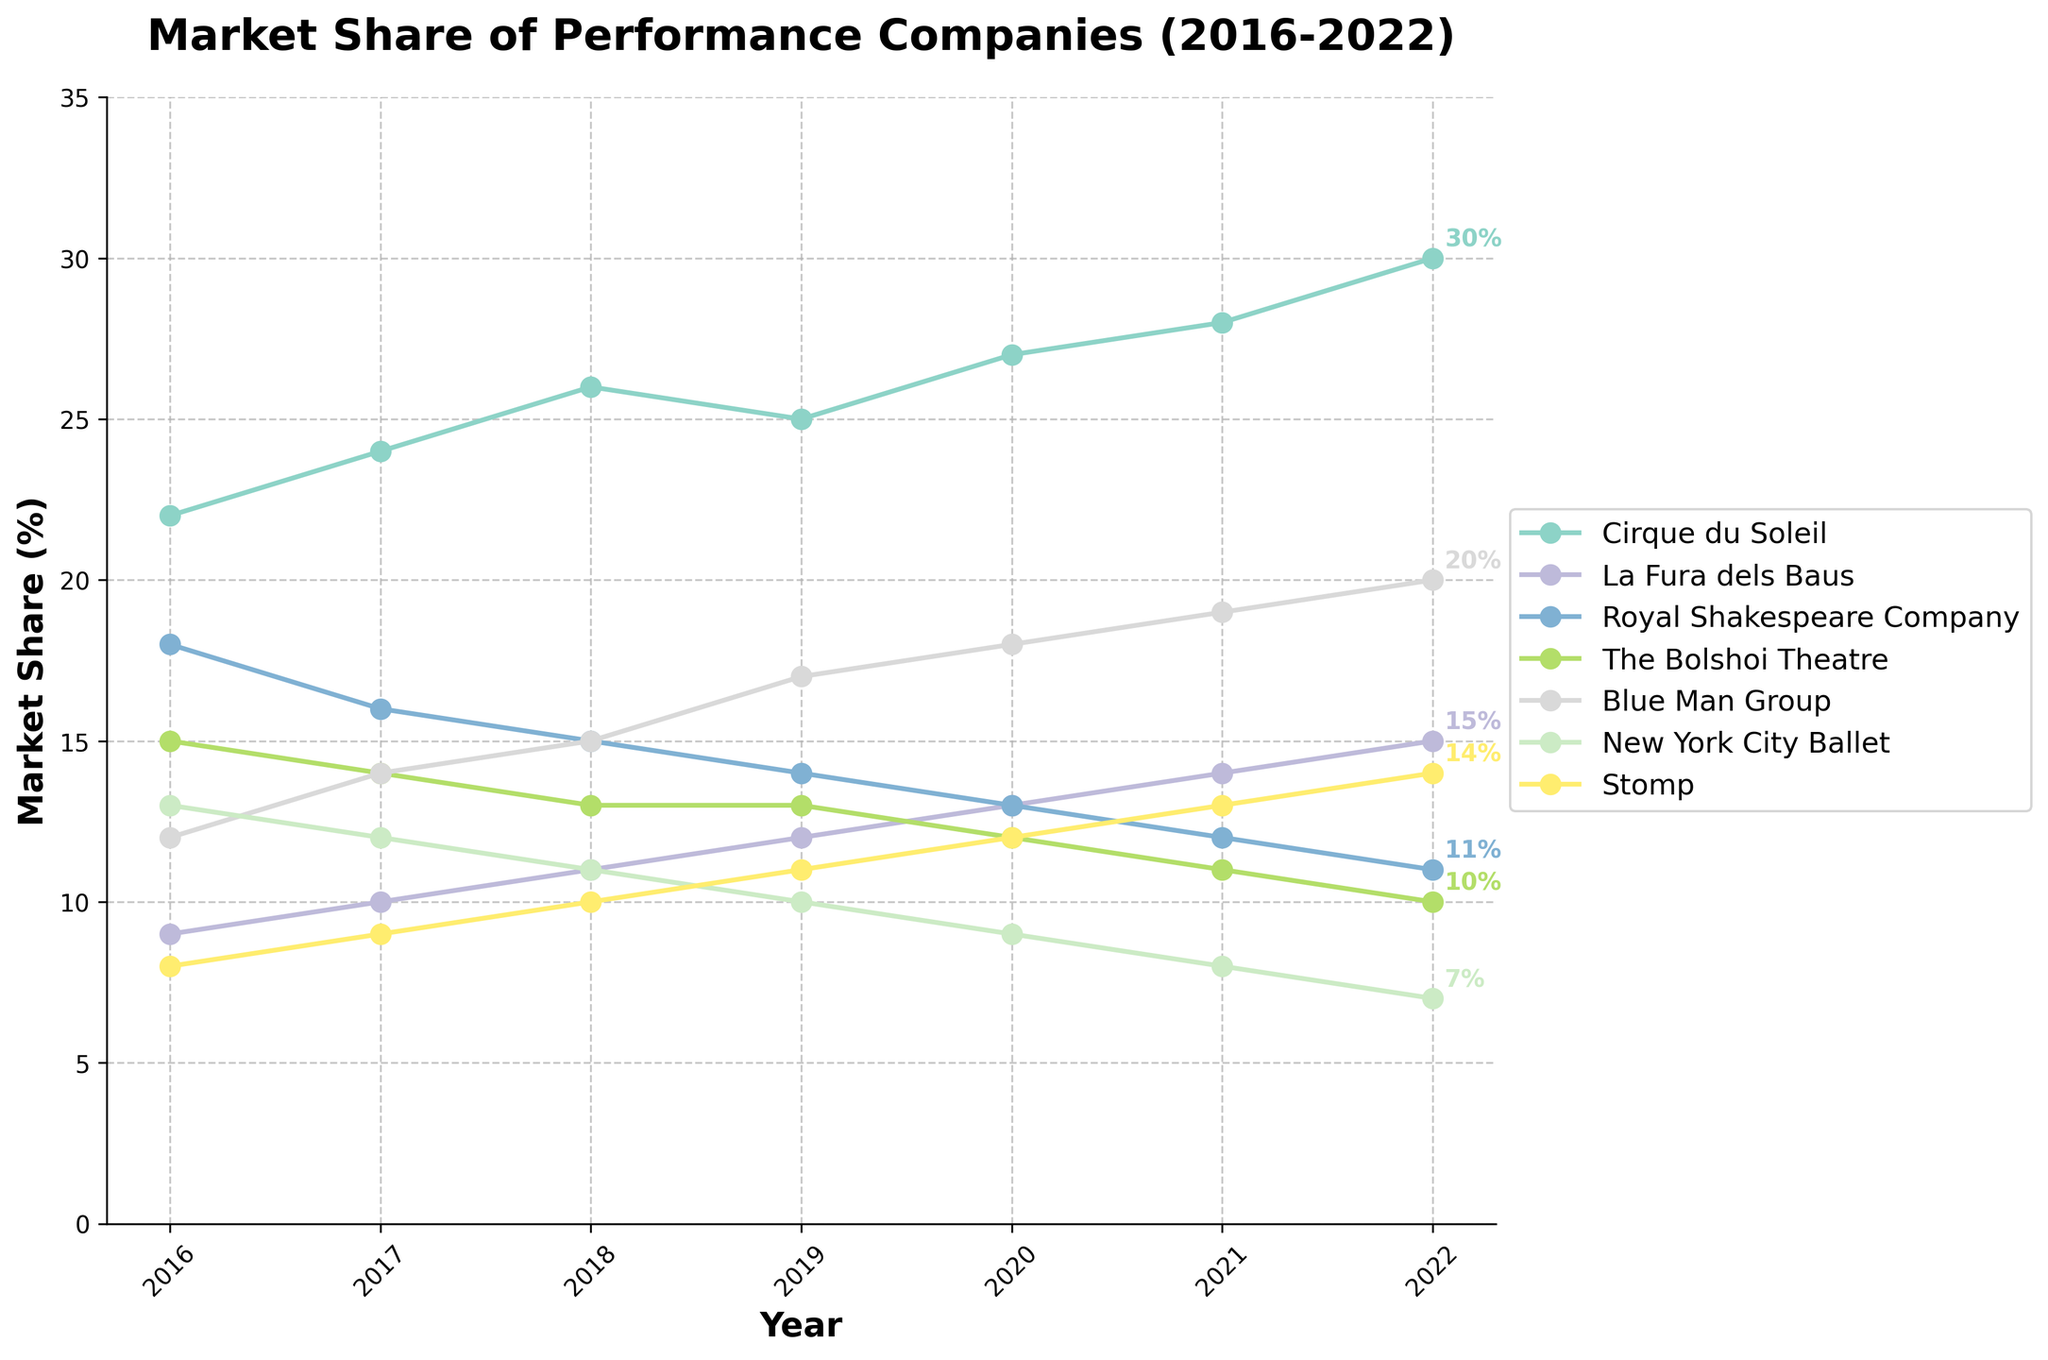What is the title of the plot? The title is usually found at the top of the plot in a larger and bold font. It provides a summary of what the plot is about. Here, the title reads "Market Share of Performance Companies (2016-2022)".
Answer: Market Share of Performance Companies (2016-2022) What are the companies categorized as innovative? The plot uses a distinct color for each company, and the legend on the right side of the plot helps identify these categories. Cirque du Soleil, La Fura dels Baus, Blue Man Group, and Stomp are labeled as innovative performance companies.
Answer: Cirque du Soleil, La Fura dels Baus, Blue Man Group, Stomp What is the range of years shown on the x-axis? The x-axis represents the years, displayed sequentially from left to right. Here, the x-axis starts from 2016 and extends to 2022.
Answer: 2016-2022 Which company had the highest market share in 2022? By looking at the trend lines and the data points labeled for 2022, we see that Cirque du Soleil had the highest market share at 30%.
Answer: Cirque du Soleil How did Blue Man Group’s market share change from 2016 to 2022? Blue Man Group’s market share changes can be traced by following its corresponding trend line across the years 2016 to 2022. It increased from 12% in 2016 to 20% in 2022.
Answer: Increased from 12% to 20% What was the market share difference between Cirque du Soleil and The Bolshoi Theatre in 2020? Locate the data points for Cirque du Soleil and The Bolshoi Theatre in 2020. Cirque du Soleil had a market share of 27%, while The Bolshoi Theatre had 12%. Subtracting these gives a difference of 15%.
Answer: 15% Which company experienced the most significant increase in market share over the seven years? By comparing the starting and ending data points of each company’s trend line, Cirque du Soleil showed the most significant increase, from 22% in 2016 to 30% in 2022, an increase of 8%.
Answer: Cirque du Soleil How does the market share trend of traditional performance companies compare to innovative performance companies? This involves comparing the general directions of the trend lines for traditional companies (Royal Shakespeare Company, The Bolshoi Theatre, New York City Ballet) against those for innovative companies. Traditional companies generally show a decreasing trend, while innovative companies show an increasing trend.
Answer: Traditional companies decreased, innovative companies increased Which company saw the smallest change in market share between 2016 and 2022? Looking at the trend lines, The Bolshoi Theatre had the smallest change, with 15% in 2016 and 10% in 2022, a decrease of just 5%.
Answer: The Bolshoi Theatre 